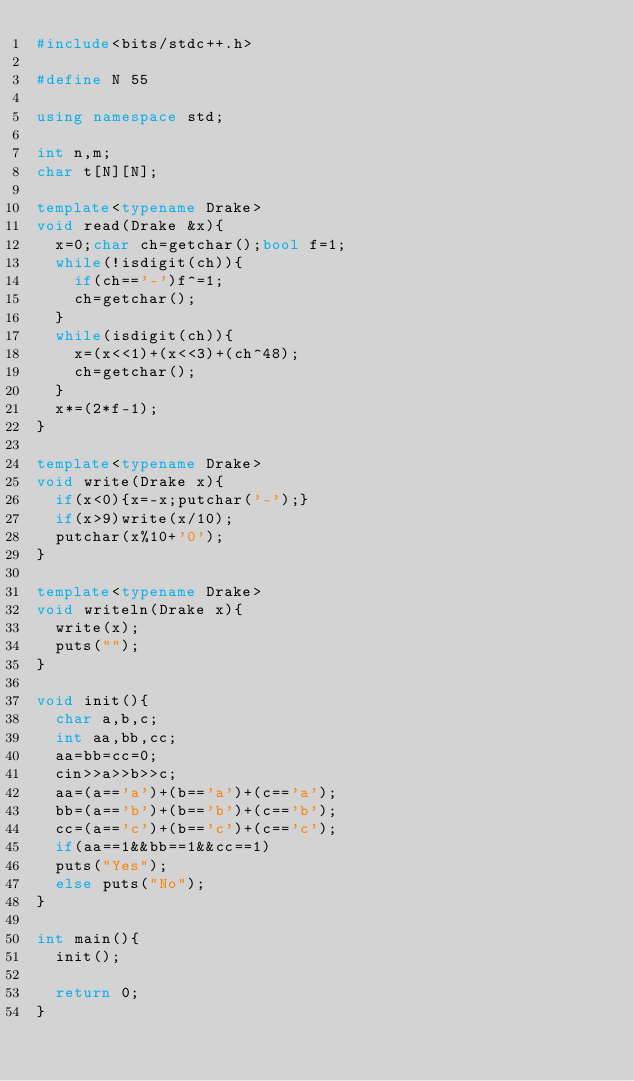Convert code to text. <code><loc_0><loc_0><loc_500><loc_500><_C++_>#include<bits/stdc++.h>

#define N 55

using namespace std;

int n,m;
char t[N][N];

template<typename Drake>
void read(Drake &x){
	x=0;char ch=getchar();bool f=1;
	while(!isdigit(ch)){
		if(ch=='-')f^=1;
		ch=getchar();
	}
	while(isdigit(ch)){
		x=(x<<1)+(x<<3)+(ch^48);
		ch=getchar();
	}
	x*=(2*f-1);
}

template<typename Drake>
void write(Drake x){
	if(x<0){x=-x;putchar('-');}
	if(x>9)write(x/10);
	putchar(x%10+'0');
}

template<typename Drake>
void writeln(Drake x){
	write(x);
	puts("");
}

void init(){
	char a,b,c;
	int aa,bb,cc;
	aa=bb=cc=0;
	cin>>a>>b>>c;
	aa=(a=='a')+(b=='a')+(c=='a');
	bb=(a=='b')+(b=='b')+(c=='b');
	cc=(a=='c')+(b=='c')+(c=='c');
	if(aa==1&&bb==1&&cc==1)
	puts("Yes");
	else puts("No");
}
 
int main(){
	init();
	
	return 0;
}</code> 